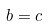<formula> <loc_0><loc_0><loc_500><loc_500>b = c</formula> 